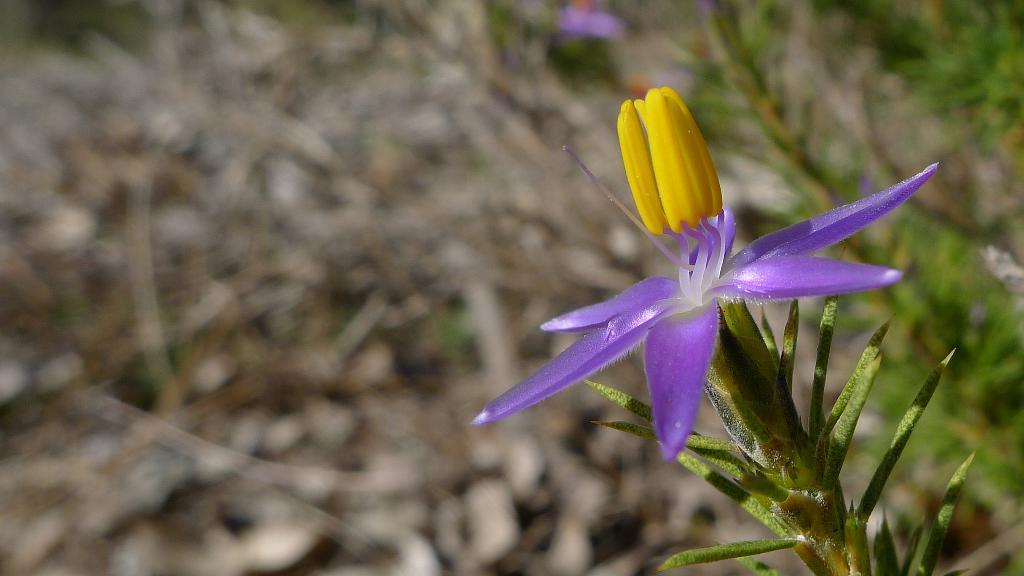What type of living organisms can be seen in the image? There are flowers and plants in the image. Can you describe the plants in the image? The plants in the image are not specified, but they are present alongside the flowers. Can you describe the interaction between the stranger and the heart in the image? There is no stranger or heart present in the image; it features flowers and plants. 